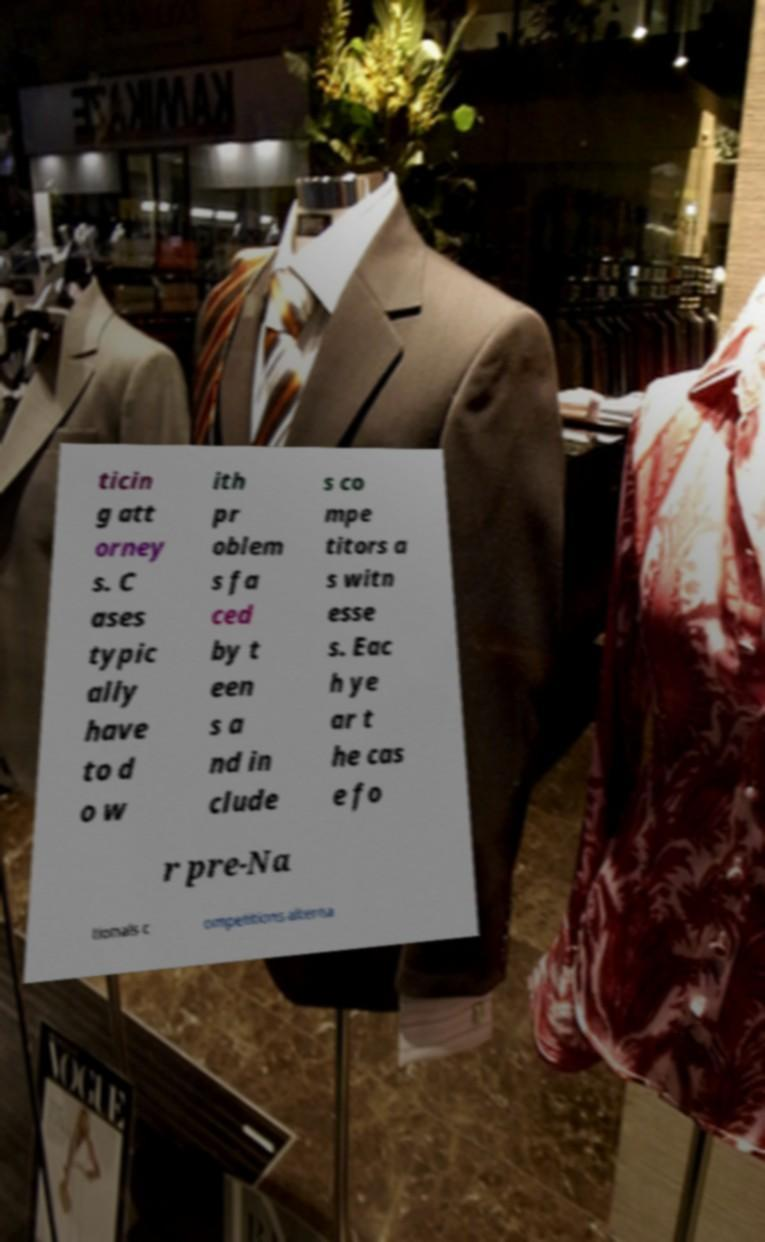There's text embedded in this image that I need extracted. Can you transcribe it verbatim? ticin g att orney s. C ases typic ally have to d o w ith pr oblem s fa ced by t een s a nd in clude s co mpe titors a s witn esse s. Eac h ye ar t he cas e fo r pre-Na tionals c ompetitions alterna 